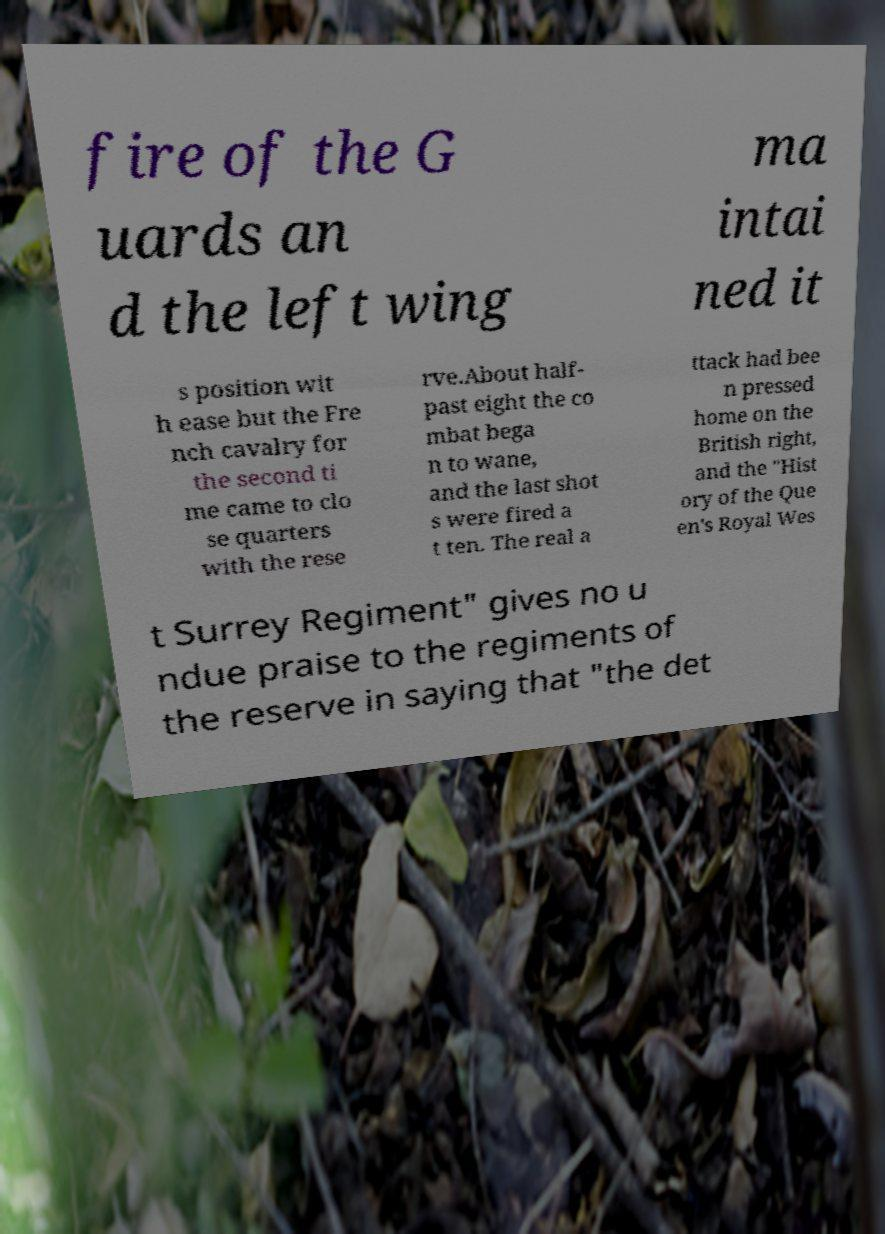Please identify and transcribe the text found in this image. fire of the G uards an d the left wing ma intai ned it s position wit h ease but the Fre nch cavalry for the second ti me came to clo se quarters with the rese rve.About half- past eight the co mbat bega n to wane, and the last shot s were fired a t ten. The real a ttack had bee n pressed home on the British right, and the "Hist ory of the Que en's Royal Wes t Surrey Regiment" gives no u ndue praise to the regiments of the reserve in saying that "the det 